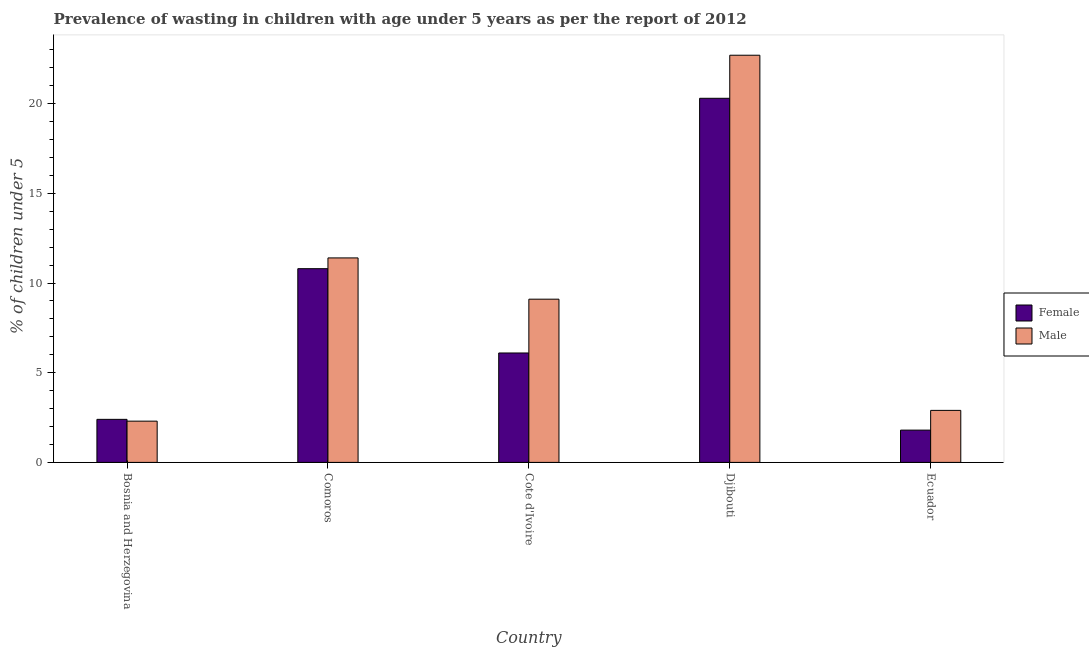How many different coloured bars are there?
Keep it short and to the point. 2. How many bars are there on the 2nd tick from the left?
Your answer should be very brief. 2. How many bars are there on the 3rd tick from the right?
Provide a succinct answer. 2. What is the label of the 2nd group of bars from the left?
Give a very brief answer. Comoros. What is the percentage of undernourished male children in Ecuador?
Your answer should be compact. 2.9. Across all countries, what is the maximum percentage of undernourished male children?
Make the answer very short. 22.7. Across all countries, what is the minimum percentage of undernourished male children?
Offer a very short reply. 2.3. In which country was the percentage of undernourished female children maximum?
Provide a succinct answer. Djibouti. In which country was the percentage of undernourished female children minimum?
Your response must be concise. Ecuador. What is the total percentage of undernourished female children in the graph?
Offer a very short reply. 41.4. What is the difference between the percentage of undernourished male children in Cote d'Ivoire and that in Djibouti?
Offer a very short reply. -13.6. What is the difference between the percentage of undernourished female children in Djibouti and the percentage of undernourished male children in Bosnia and Herzegovina?
Offer a terse response. 18. What is the average percentage of undernourished male children per country?
Provide a succinct answer. 9.68. What is the difference between the percentage of undernourished male children and percentage of undernourished female children in Bosnia and Herzegovina?
Offer a very short reply. -0.1. In how many countries, is the percentage of undernourished male children greater than 21 %?
Your answer should be very brief. 1. What is the ratio of the percentage of undernourished male children in Cote d'Ivoire to that in Ecuador?
Provide a short and direct response. 3.14. Is the difference between the percentage of undernourished female children in Bosnia and Herzegovina and Djibouti greater than the difference between the percentage of undernourished male children in Bosnia and Herzegovina and Djibouti?
Make the answer very short. Yes. What is the difference between the highest and the second highest percentage of undernourished male children?
Make the answer very short. 11.3. What is the difference between the highest and the lowest percentage of undernourished female children?
Ensure brevity in your answer.  18.5. What does the 1st bar from the right in Djibouti represents?
Keep it short and to the point. Male. Are all the bars in the graph horizontal?
Give a very brief answer. No. Does the graph contain any zero values?
Provide a short and direct response. No. Does the graph contain grids?
Offer a very short reply. No. Where does the legend appear in the graph?
Ensure brevity in your answer.  Center right. How many legend labels are there?
Your answer should be very brief. 2. How are the legend labels stacked?
Your response must be concise. Vertical. What is the title of the graph?
Give a very brief answer. Prevalence of wasting in children with age under 5 years as per the report of 2012. What is the label or title of the Y-axis?
Your answer should be very brief.  % of children under 5. What is the  % of children under 5 of Female in Bosnia and Herzegovina?
Give a very brief answer. 2.4. What is the  % of children under 5 in Male in Bosnia and Herzegovina?
Your answer should be compact. 2.3. What is the  % of children under 5 of Female in Comoros?
Your response must be concise. 10.8. What is the  % of children under 5 in Male in Comoros?
Provide a short and direct response. 11.4. What is the  % of children under 5 of Female in Cote d'Ivoire?
Offer a very short reply. 6.1. What is the  % of children under 5 of Male in Cote d'Ivoire?
Make the answer very short. 9.1. What is the  % of children under 5 in Female in Djibouti?
Provide a short and direct response. 20.3. What is the  % of children under 5 in Male in Djibouti?
Provide a short and direct response. 22.7. What is the  % of children under 5 in Female in Ecuador?
Keep it short and to the point. 1.8. What is the  % of children under 5 of Male in Ecuador?
Give a very brief answer. 2.9. Across all countries, what is the maximum  % of children under 5 in Female?
Your answer should be compact. 20.3. Across all countries, what is the maximum  % of children under 5 of Male?
Offer a terse response. 22.7. Across all countries, what is the minimum  % of children under 5 in Female?
Ensure brevity in your answer.  1.8. Across all countries, what is the minimum  % of children under 5 in Male?
Make the answer very short. 2.3. What is the total  % of children under 5 of Female in the graph?
Offer a terse response. 41.4. What is the total  % of children under 5 of Male in the graph?
Offer a very short reply. 48.4. What is the difference between the  % of children under 5 of Female in Bosnia and Herzegovina and that in Comoros?
Your answer should be very brief. -8.4. What is the difference between the  % of children under 5 of Female in Bosnia and Herzegovina and that in Djibouti?
Provide a succinct answer. -17.9. What is the difference between the  % of children under 5 of Male in Bosnia and Herzegovina and that in Djibouti?
Your answer should be compact. -20.4. What is the difference between the  % of children under 5 in Male in Comoros and that in Cote d'Ivoire?
Your answer should be very brief. 2.3. What is the difference between the  % of children under 5 of Female in Comoros and that in Djibouti?
Provide a succinct answer. -9.5. What is the difference between the  % of children under 5 of Male in Comoros and that in Djibouti?
Give a very brief answer. -11.3. What is the difference between the  % of children under 5 in Female in Comoros and that in Ecuador?
Your answer should be very brief. 9. What is the difference between the  % of children under 5 of Male in Comoros and that in Ecuador?
Provide a short and direct response. 8.5. What is the difference between the  % of children under 5 of Female in Cote d'Ivoire and that in Djibouti?
Make the answer very short. -14.2. What is the difference between the  % of children under 5 of Female in Cote d'Ivoire and that in Ecuador?
Your answer should be very brief. 4.3. What is the difference between the  % of children under 5 of Male in Cote d'Ivoire and that in Ecuador?
Keep it short and to the point. 6.2. What is the difference between the  % of children under 5 of Female in Djibouti and that in Ecuador?
Keep it short and to the point. 18.5. What is the difference between the  % of children under 5 in Male in Djibouti and that in Ecuador?
Your response must be concise. 19.8. What is the difference between the  % of children under 5 in Female in Bosnia and Herzegovina and the  % of children under 5 in Male in Comoros?
Keep it short and to the point. -9. What is the difference between the  % of children under 5 in Female in Bosnia and Herzegovina and the  % of children under 5 in Male in Djibouti?
Keep it short and to the point. -20.3. What is the difference between the  % of children under 5 of Female in Comoros and the  % of children under 5 of Male in Cote d'Ivoire?
Your answer should be very brief. 1.7. What is the difference between the  % of children under 5 in Female in Cote d'Ivoire and the  % of children under 5 in Male in Djibouti?
Make the answer very short. -16.6. What is the difference between the  % of children under 5 in Female in Cote d'Ivoire and the  % of children under 5 in Male in Ecuador?
Provide a succinct answer. 3.2. What is the difference between the  % of children under 5 of Female in Djibouti and the  % of children under 5 of Male in Ecuador?
Keep it short and to the point. 17.4. What is the average  % of children under 5 in Female per country?
Make the answer very short. 8.28. What is the average  % of children under 5 of Male per country?
Make the answer very short. 9.68. What is the difference between the  % of children under 5 in Female and  % of children under 5 in Male in Bosnia and Herzegovina?
Offer a very short reply. 0.1. What is the difference between the  % of children under 5 in Female and  % of children under 5 in Male in Cote d'Ivoire?
Provide a succinct answer. -3. What is the ratio of the  % of children under 5 of Female in Bosnia and Herzegovina to that in Comoros?
Provide a succinct answer. 0.22. What is the ratio of the  % of children under 5 in Male in Bosnia and Herzegovina to that in Comoros?
Offer a very short reply. 0.2. What is the ratio of the  % of children under 5 in Female in Bosnia and Herzegovina to that in Cote d'Ivoire?
Keep it short and to the point. 0.39. What is the ratio of the  % of children under 5 in Male in Bosnia and Herzegovina to that in Cote d'Ivoire?
Your answer should be compact. 0.25. What is the ratio of the  % of children under 5 in Female in Bosnia and Herzegovina to that in Djibouti?
Provide a succinct answer. 0.12. What is the ratio of the  % of children under 5 of Male in Bosnia and Herzegovina to that in Djibouti?
Offer a very short reply. 0.1. What is the ratio of the  % of children under 5 of Male in Bosnia and Herzegovina to that in Ecuador?
Keep it short and to the point. 0.79. What is the ratio of the  % of children under 5 of Female in Comoros to that in Cote d'Ivoire?
Offer a very short reply. 1.77. What is the ratio of the  % of children under 5 of Male in Comoros to that in Cote d'Ivoire?
Ensure brevity in your answer.  1.25. What is the ratio of the  % of children under 5 in Female in Comoros to that in Djibouti?
Offer a terse response. 0.53. What is the ratio of the  % of children under 5 in Male in Comoros to that in Djibouti?
Give a very brief answer. 0.5. What is the ratio of the  % of children under 5 in Female in Comoros to that in Ecuador?
Make the answer very short. 6. What is the ratio of the  % of children under 5 of Male in Comoros to that in Ecuador?
Offer a terse response. 3.93. What is the ratio of the  % of children under 5 of Female in Cote d'Ivoire to that in Djibouti?
Make the answer very short. 0.3. What is the ratio of the  % of children under 5 in Male in Cote d'Ivoire to that in Djibouti?
Give a very brief answer. 0.4. What is the ratio of the  % of children under 5 in Female in Cote d'Ivoire to that in Ecuador?
Keep it short and to the point. 3.39. What is the ratio of the  % of children under 5 of Male in Cote d'Ivoire to that in Ecuador?
Provide a short and direct response. 3.14. What is the ratio of the  % of children under 5 in Female in Djibouti to that in Ecuador?
Keep it short and to the point. 11.28. What is the ratio of the  % of children under 5 in Male in Djibouti to that in Ecuador?
Your answer should be very brief. 7.83. What is the difference between the highest and the second highest  % of children under 5 of Female?
Keep it short and to the point. 9.5. What is the difference between the highest and the second highest  % of children under 5 in Male?
Provide a short and direct response. 11.3. What is the difference between the highest and the lowest  % of children under 5 in Female?
Offer a very short reply. 18.5. What is the difference between the highest and the lowest  % of children under 5 of Male?
Keep it short and to the point. 20.4. 